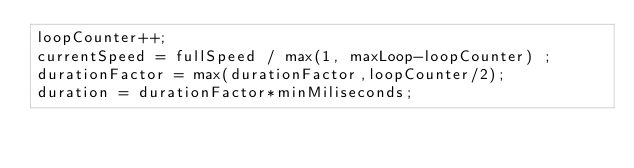<code> <loc_0><loc_0><loc_500><loc_500><_ObjectiveC_>loopCounter++;
currentSpeed = fullSpeed / max(1, maxLoop-loopCounter) ;
durationFactor = max(durationFactor,loopCounter/2); 
duration = durationFactor*minMiliseconds;
</code> 